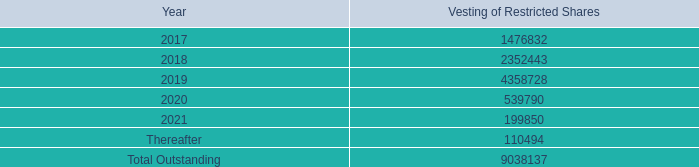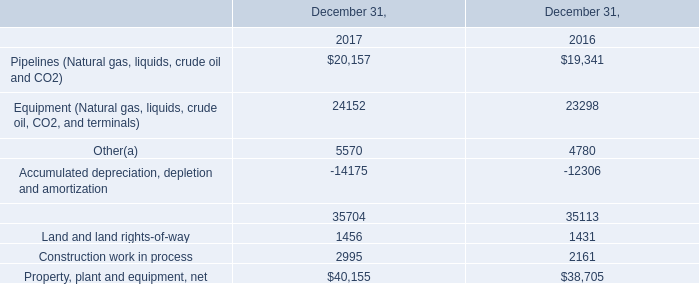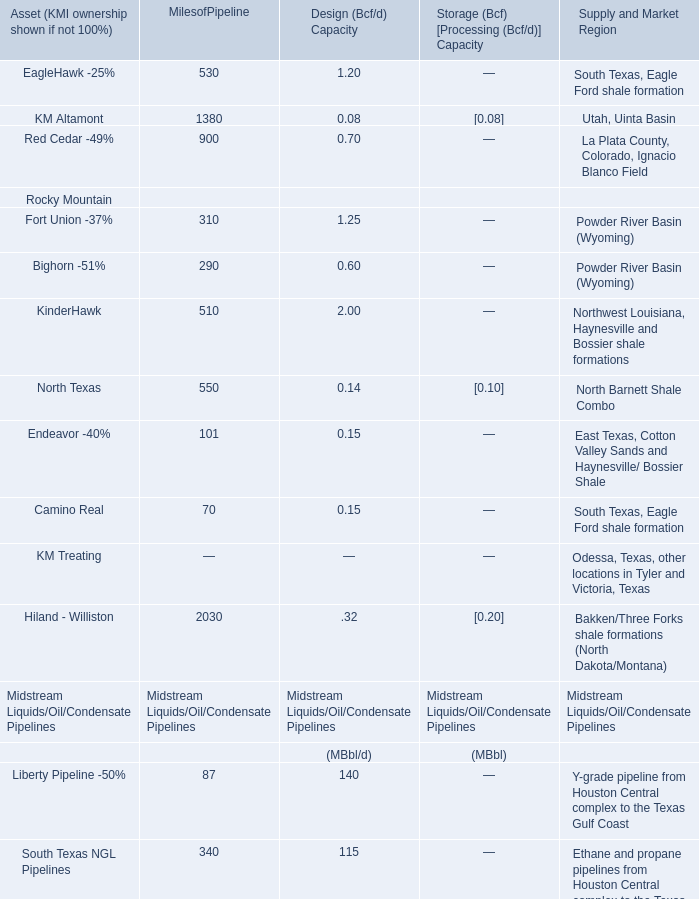What was the total amount of (MBbl/d) for Midstream Liquids/Oil/Condensate Pipelines? 
Computations: ((((140 + 115) + 110) + 282) + 220)
Answer: 867.0. 